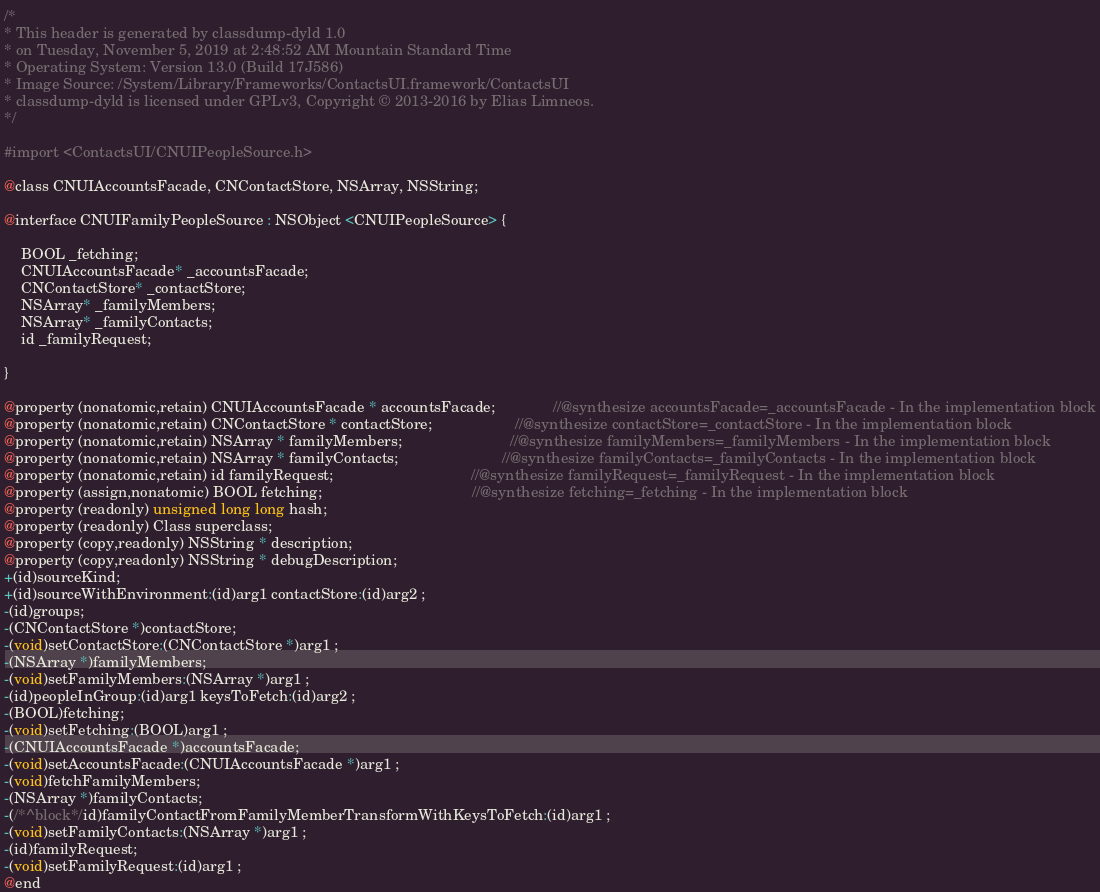<code> <loc_0><loc_0><loc_500><loc_500><_C_>/*
* This header is generated by classdump-dyld 1.0
* on Tuesday, November 5, 2019 at 2:48:52 AM Mountain Standard Time
* Operating System: Version 13.0 (Build 17J586)
* Image Source: /System/Library/Frameworks/ContactsUI.framework/ContactsUI
* classdump-dyld is licensed under GPLv3, Copyright © 2013-2016 by Elias Limneos.
*/

#import <ContactsUI/CNUIPeopleSource.h>

@class CNUIAccountsFacade, CNContactStore, NSArray, NSString;

@interface CNUIFamilyPeopleSource : NSObject <CNUIPeopleSource> {

	BOOL _fetching;
	CNUIAccountsFacade* _accountsFacade;
	CNContactStore* _contactStore;
	NSArray* _familyMembers;
	NSArray* _familyContacts;
	id _familyRequest;

}

@property (nonatomic,retain) CNUIAccountsFacade * accountsFacade;              //@synthesize accountsFacade=_accountsFacade - In the implementation block
@property (nonatomic,retain) CNContactStore * contactStore;                    //@synthesize contactStore=_contactStore - In the implementation block
@property (nonatomic,retain) NSArray * familyMembers;                          //@synthesize familyMembers=_familyMembers - In the implementation block
@property (nonatomic,retain) NSArray * familyContacts;                         //@synthesize familyContacts=_familyContacts - In the implementation block
@property (nonatomic,retain) id familyRequest;                                 //@synthesize familyRequest=_familyRequest - In the implementation block
@property (assign,nonatomic) BOOL fetching;                                    //@synthesize fetching=_fetching - In the implementation block
@property (readonly) unsigned long long hash; 
@property (readonly) Class superclass; 
@property (copy,readonly) NSString * description; 
@property (copy,readonly) NSString * debugDescription; 
+(id)sourceKind;
+(id)sourceWithEnvironment:(id)arg1 contactStore:(id)arg2 ;
-(id)groups;
-(CNContactStore *)contactStore;
-(void)setContactStore:(CNContactStore *)arg1 ;
-(NSArray *)familyMembers;
-(void)setFamilyMembers:(NSArray *)arg1 ;
-(id)peopleInGroup:(id)arg1 keysToFetch:(id)arg2 ;
-(BOOL)fetching;
-(void)setFetching:(BOOL)arg1 ;
-(CNUIAccountsFacade *)accountsFacade;
-(void)setAccountsFacade:(CNUIAccountsFacade *)arg1 ;
-(void)fetchFamilyMembers;
-(NSArray *)familyContacts;
-(/*^block*/id)familyContactFromFamilyMemberTransformWithKeysToFetch:(id)arg1 ;
-(void)setFamilyContacts:(NSArray *)arg1 ;
-(id)familyRequest;
-(void)setFamilyRequest:(id)arg1 ;
@end

</code> 